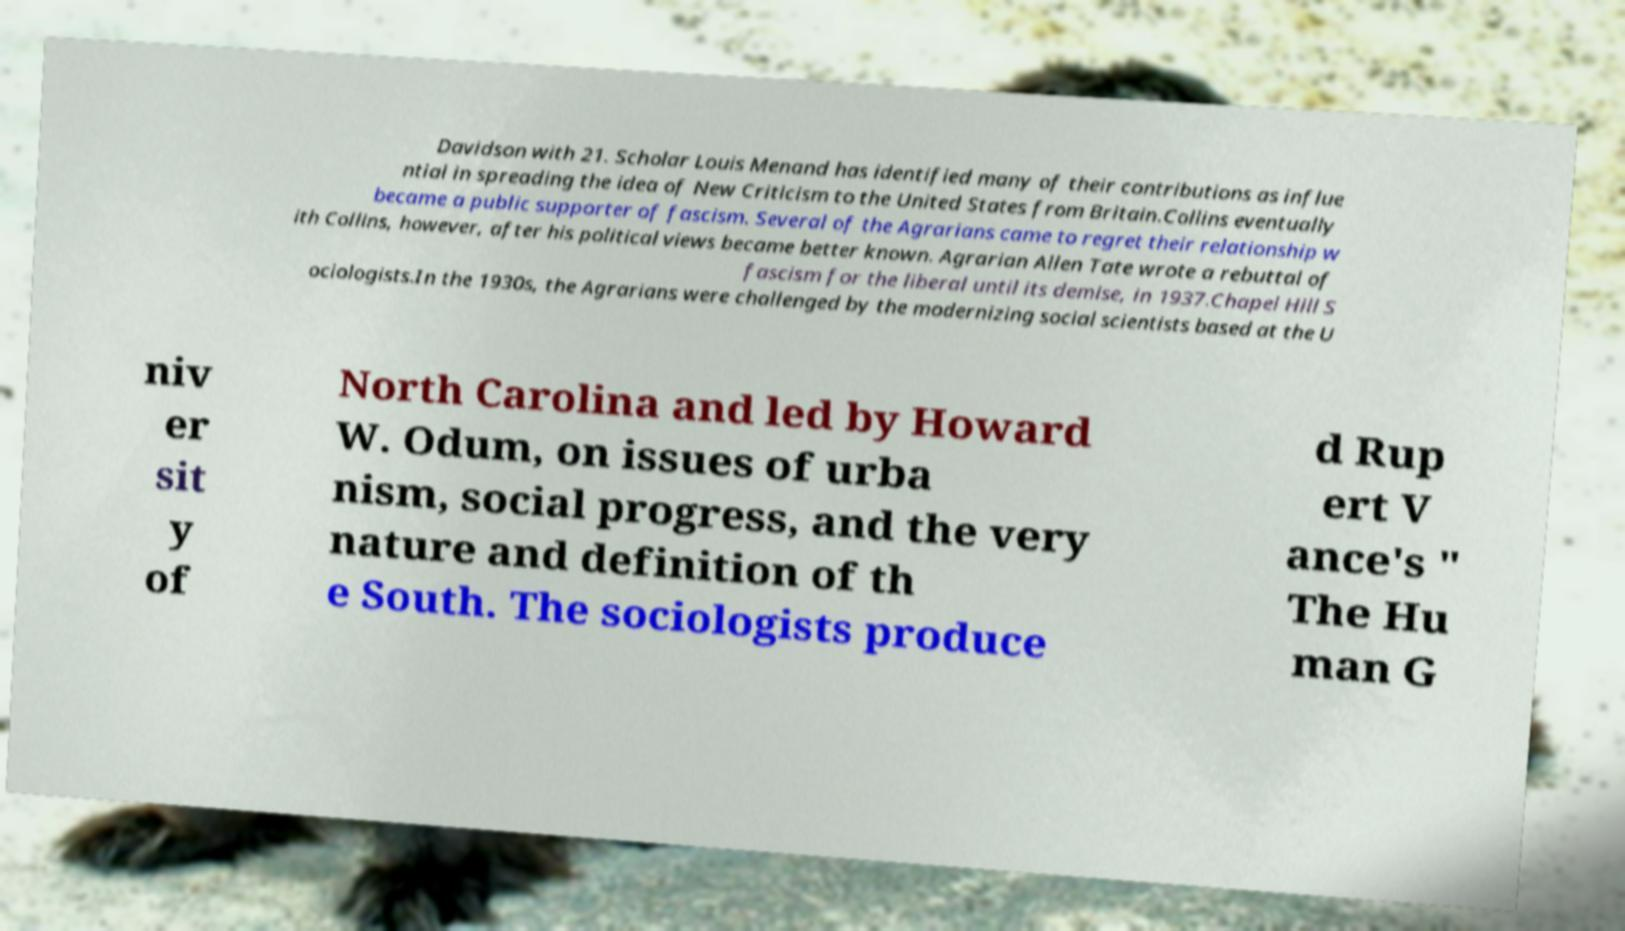Please read and relay the text visible in this image. What does it say? Davidson with 21. Scholar Louis Menand has identified many of their contributions as influe ntial in spreading the idea of New Criticism to the United States from Britain.Collins eventually became a public supporter of fascism. Several of the Agrarians came to regret their relationship w ith Collins, however, after his political views became better known. Agrarian Allen Tate wrote a rebuttal of fascism for the liberal until its demise, in 1937.Chapel Hill S ociologists.In the 1930s, the Agrarians were challenged by the modernizing social scientists based at the U niv er sit y of North Carolina and led by Howard W. Odum, on issues of urba nism, social progress, and the very nature and definition of th e South. The sociologists produce d Rup ert V ance's " The Hu man G 